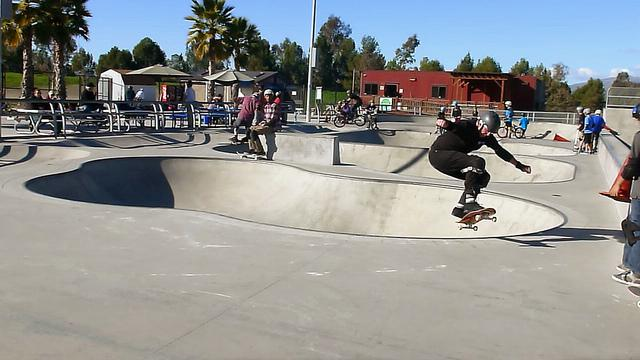Where are the skaters located?

Choices:
A) street
B) store
C) park
D) mall park 